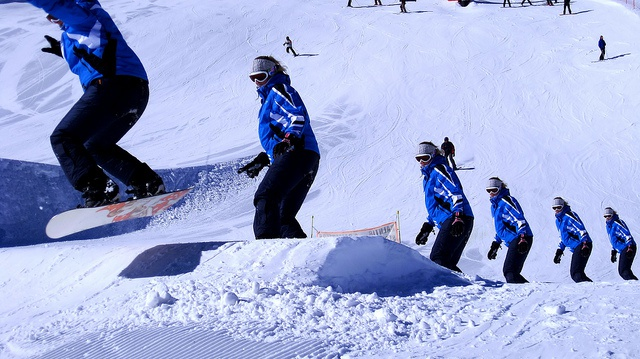Describe the objects in this image and their specific colors. I can see people in blue, black, navy, and darkblue tones, people in blue, black, navy, and darkblue tones, people in blue, black, navy, and darkblue tones, snowboard in blue, lavender, and darkgray tones, and people in blue, black, navy, and darkblue tones in this image. 